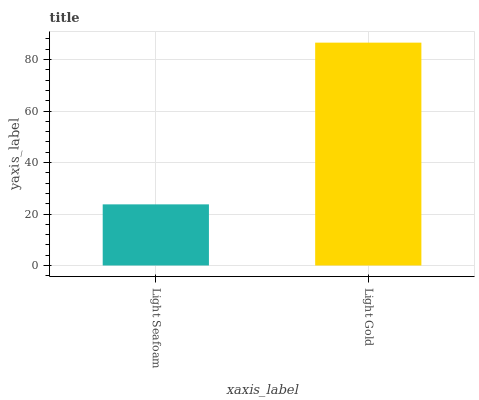Is Light Gold the minimum?
Answer yes or no. No. Is Light Gold greater than Light Seafoam?
Answer yes or no. Yes. Is Light Seafoam less than Light Gold?
Answer yes or no. Yes. Is Light Seafoam greater than Light Gold?
Answer yes or no. No. Is Light Gold less than Light Seafoam?
Answer yes or no. No. Is Light Gold the high median?
Answer yes or no. Yes. Is Light Seafoam the low median?
Answer yes or no. Yes. Is Light Seafoam the high median?
Answer yes or no. No. Is Light Gold the low median?
Answer yes or no. No. 